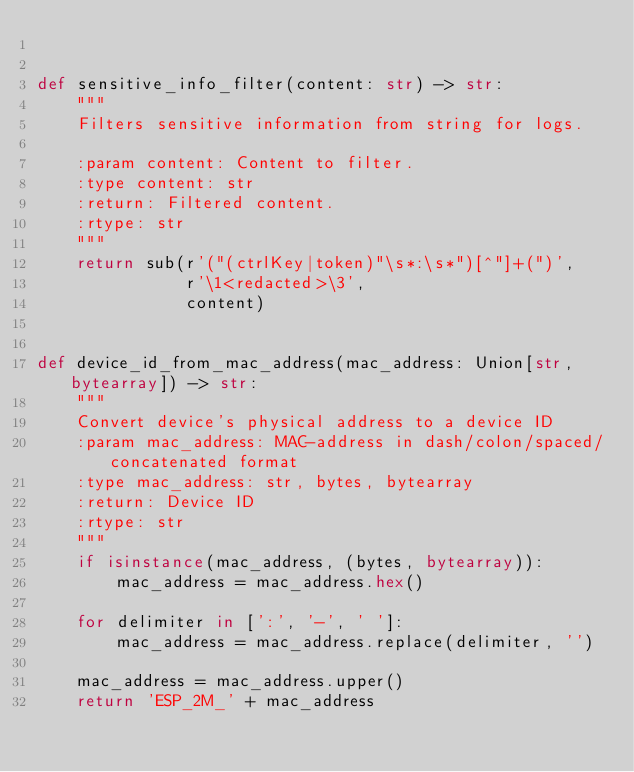<code> <loc_0><loc_0><loc_500><loc_500><_Python_>

def sensitive_info_filter(content: str) -> str:
    """
    Filters sensitive information from string for logs.

    :param content: Content to filter.
    :type content: str
    :return: Filtered content.
    :rtype: str
    """
    return sub(r'("(ctrlKey|token)"\s*:\s*")[^"]+(")',
               r'\1<redacted>\3',
               content)


def device_id_from_mac_address(mac_address: Union[str, bytearray]) -> str:
    """
    Convert device's physical address to a device ID
    :param mac_address: MAC-address in dash/colon/spaced/concatenated format
    :type mac_address: str, bytes, bytearray
    :return: Device ID
    :rtype: str
    """
    if isinstance(mac_address, (bytes, bytearray)):
        mac_address = mac_address.hex()

    for delimiter in [':', '-', ' ']:
        mac_address = mac_address.replace(delimiter, '')

    mac_address = mac_address.upper()
    return 'ESP_2M_' + mac_address
</code> 